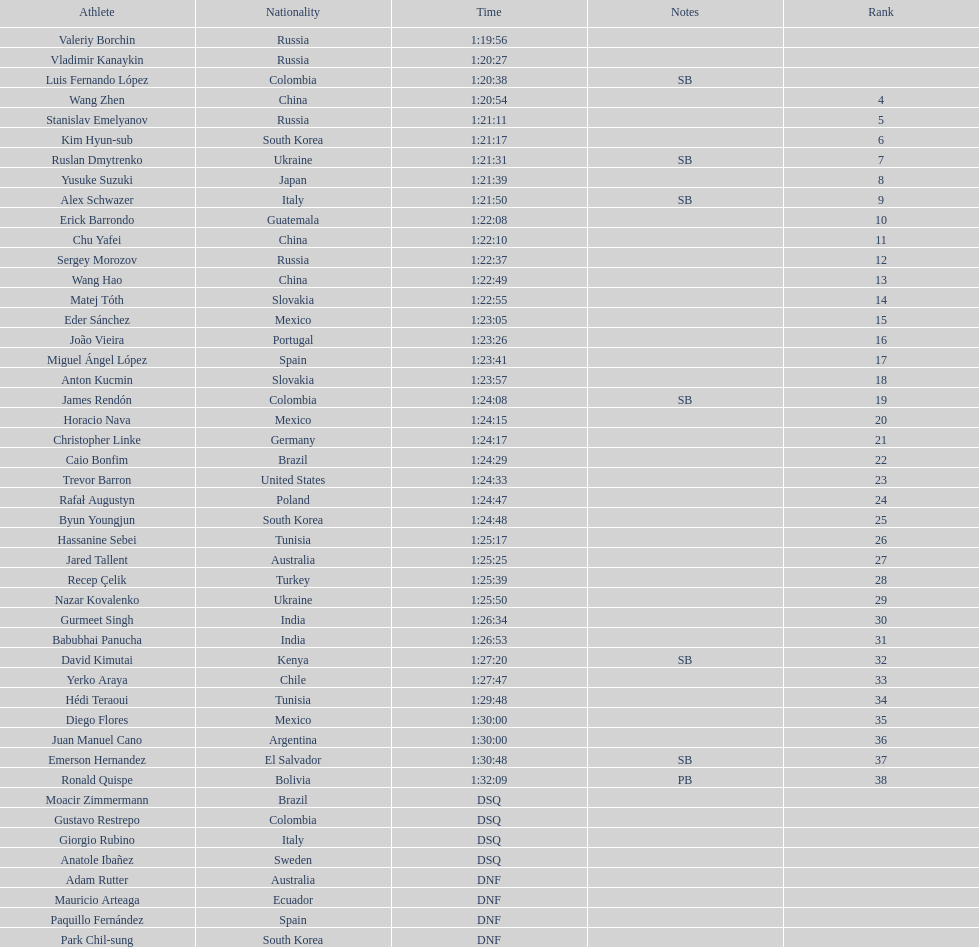Which athlete had the fastest time for the 20km? Valeriy Borchin. 